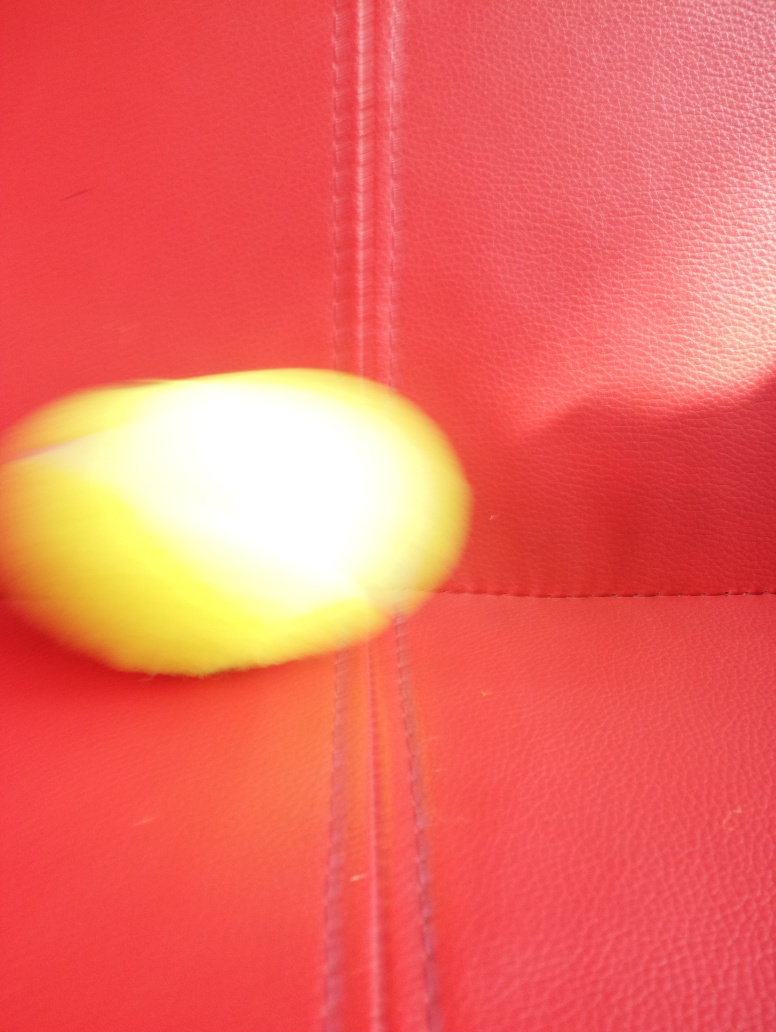Is the photo of high clarity? Option B, No, would be correct. The photo is not of high clarity as it appears to be blurred, particularly in the area capturing the yellow object, which lacks sharpness and detail. Additionally, the background does not provide any clear context, which further decreases the overall clarity of the image. 